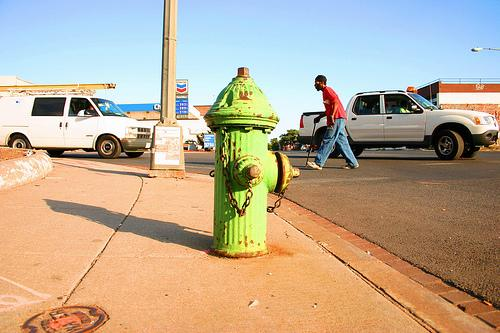Describe the type of vehicle that is turning the corner around the man. A white pickup truck with four doors is turning the corner around the man. What is visible on the roof of the white van in the image? A ladder is visible on the roof of the white van. Identify an object in the image that could help the person walking across the street with stability? A cane in the person's hand provides stability while walking. In a single sentence, describe the condition and appearance of the sidewalk. The cemented sidewalk is dry and features a utility cover and a rusty green fire hydrant. Please explain in few words the type and color of the fire hydrant in the image. The fire hydrant is bright green and rusty. Please mention the brand of the gas station and state where its sign is placed. It is a Chevron gas station, and its price sign is placed above the fire hydrant. Describe the type of vehicle stopped at the intersection. A white utility van is waiting at the intersection. What type of object is located near the edge of the sidewalk, and what is its current state? A fire hydrant is located near the edge of the sidewalk, and it shows signs of rusting. The man in the image is crossing the street. What is assisting him to walk? The man is using a cane to assist his walking. What color is the shirt of the man walking across the street? The man is wearing a red shirt. 